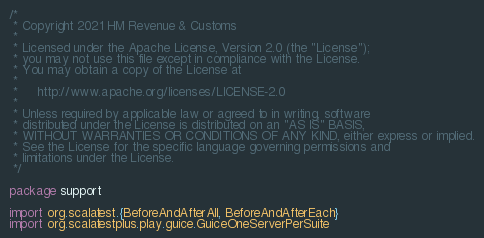Convert code to text. <code><loc_0><loc_0><loc_500><loc_500><_Scala_>/*
 * Copyright 2021 HM Revenue & Customs
 *
 * Licensed under the Apache License, Version 2.0 (the "License");
 * you may not use this file except in compliance with the License.
 * You may obtain a copy of the License at
 *
 *     http://www.apache.org/licenses/LICENSE-2.0
 *
 * Unless required by applicable law or agreed to in writing, software
 * distributed under the License is distributed on an "AS IS" BASIS,
 * WITHOUT WARRANTIES OR CONDITIONS OF ANY KIND, either express or implied.
 * See the License for the specific language governing permissions and
 * limitations under the License.
 */

package support

import org.scalatest.{BeforeAndAfterAll, BeforeAndAfterEach}
import org.scalatestplus.play.guice.GuiceOneServerPerSuite</code> 